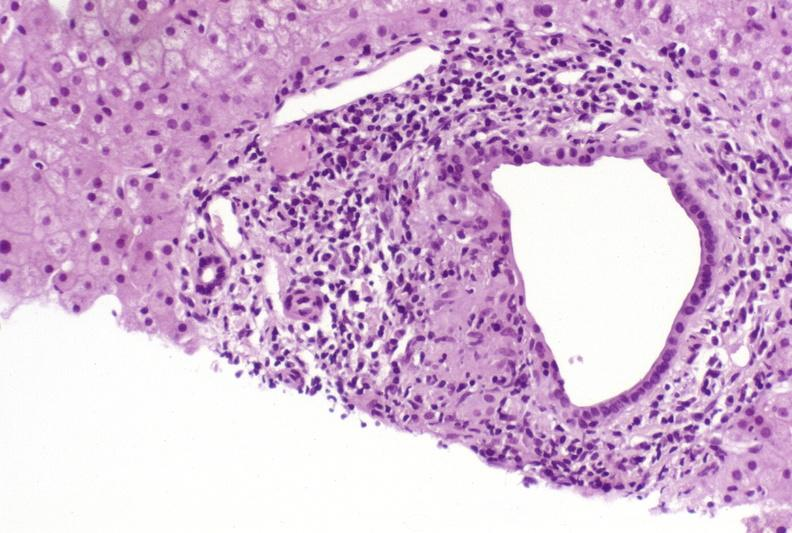what is present?
Answer the question using a single word or phrase. Liver 